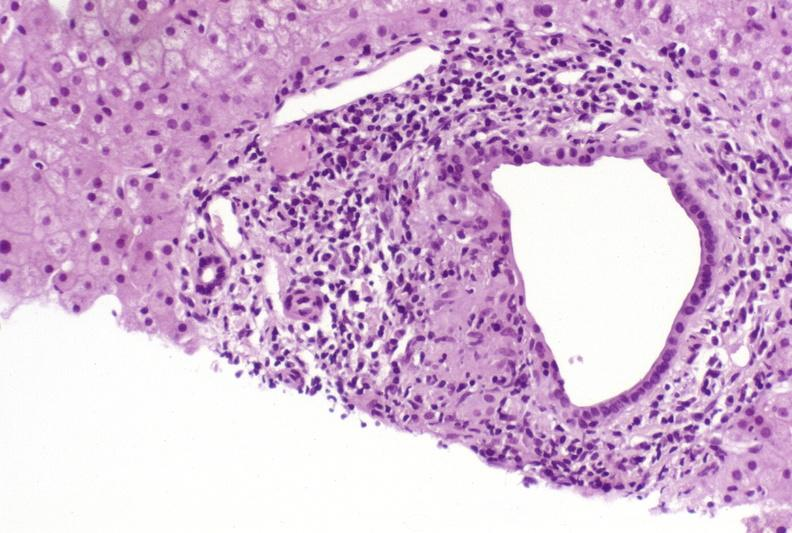what is present?
Answer the question using a single word or phrase. Liver 